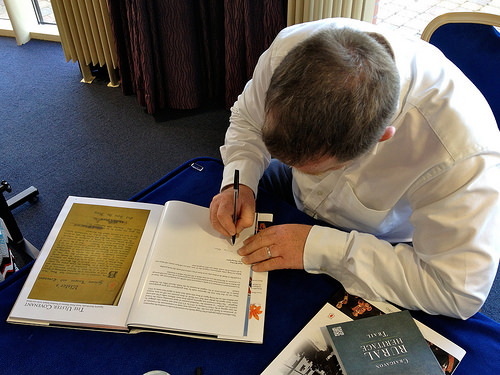<image>
Is the ink in the pen? Yes. The ink is contained within or inside the pen, showing a containment relationship. 